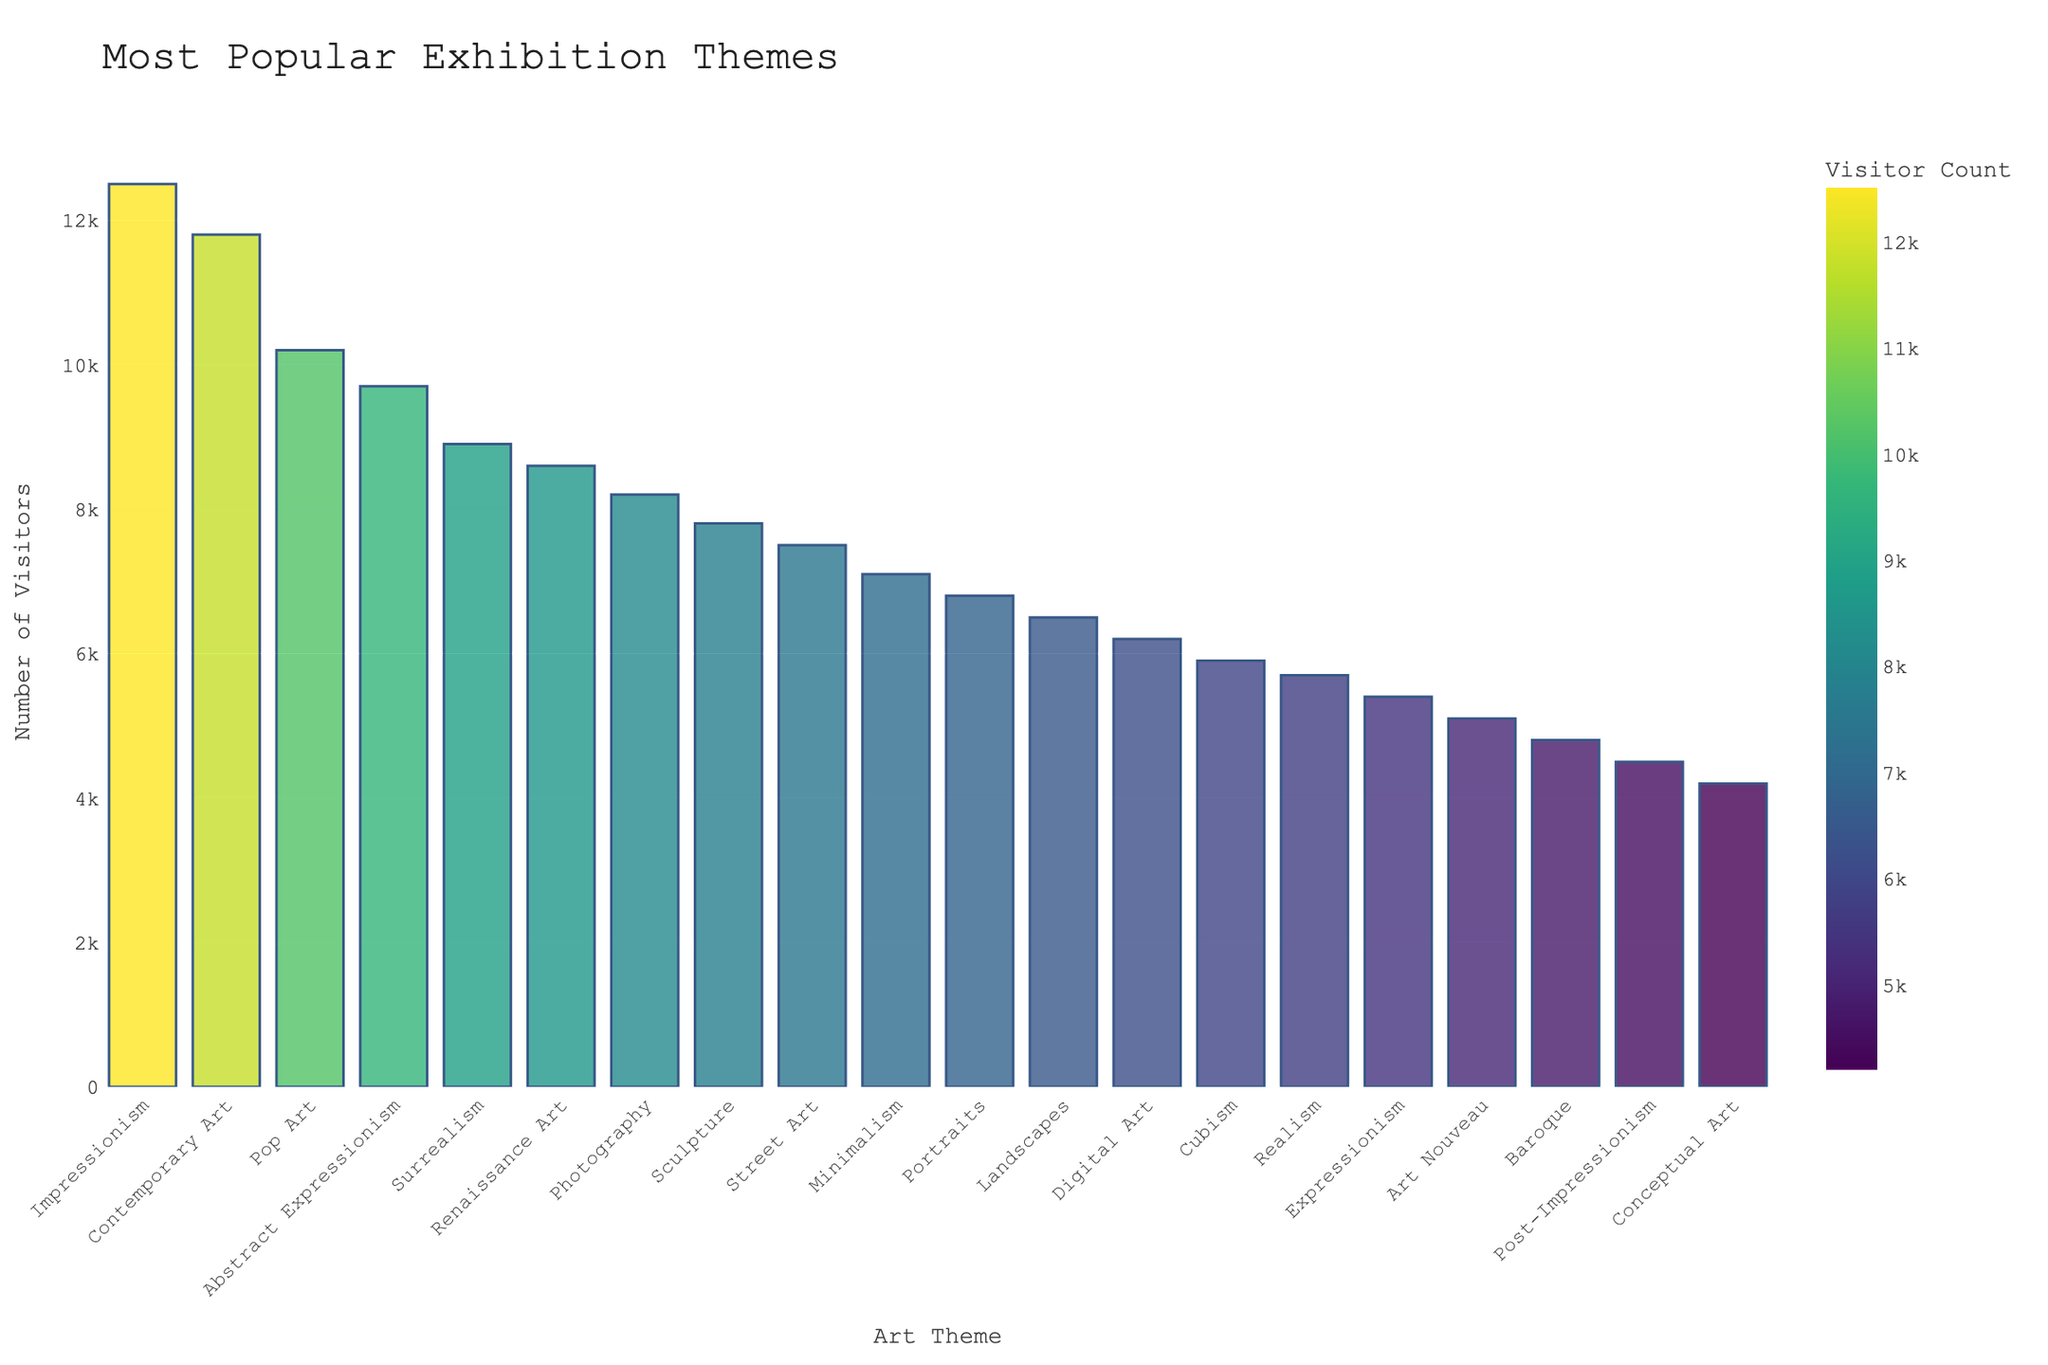What is the theme with the highest attendance? The tallest bar in the chart represents the theme with the highest attendance. This bar corresponds to Impressionism with an attendance of 12,500.
Answer: Impressionism How much higher is the attendance for Impressionism compared to Realism? Find the attendance for both themes: Impressionism (12,500) and Realism (5,700). Then, subtract the attendance of Realism from Impressionism: 12,500 - 5,700 = 6,800.
Answer: 6,800 Which theme has the lowest attendance? The shortest bar in the chart represents the theme with the lowest attendance. This bar corresponds to Conceptual Art with an attendance of 4,200.
Answer: Conceptual Art What is the total attendance for the top three most popular themes? The top three themes based on attendance are Impressionism (12,500), Contemporary Art (11,800), and Pop Art (10,200). Add these numbers together: 12,500 + 11,800 + 10,200 = 34,500.
Answer: 34,500 Which themes have an attendance greater than 10,000? Identify the bars that have heights surpassing the 10,000 attendance mark. These themes are Impressionism (12,500), Contemporary Art (11,800), and Pop Art (10,200).
Answer: Impressionism, Contemporary Art, Pop Art How many themes have an attendance between 6,000 and 9,000? Identify and count the bars whose attendance values fall within the range of 6,000 to 9,000. These themes are Surrealism (8,900), Renaissance Art (8,600), Photography (8,200), Sculpture (7,800), Street Art (7,500), Minimalism (7,100), Portraits (6,800), and Landscapes (6,500). Therefore, there are 8 themes within this range.
Answer: 8 What is the median attendance of all themes? Organize the attendance values in ascending order: 4,200, 4,500, 5,100, 5,400, 5,700, 5,900, 6,200, 6,500, 6,800, 7,100, 7,500, 7,800, 8,200, 8,600, 8,900, 9,700, 10,200, 11,800, 12,500. Since there are 20 themes, the median is the average of the 10th and 11th values: (7,100 + 7,500) / 2 = 7,300.
Answer: 7,300 Which theme has a similar attendance as Surrealism? Find the bar closest in height to Surrealism (8,900). The theme Renaissance Art has a similar attendance with 8,600.
Answer: Renaissance Art By how much does the attendance of Abstract Expressionism exceed that of Baroque? First, find the attendance values: Abstract Expressionism (9,700) and Baroque (4,800). Subtract the attendance of Baroque from Abstract Expressionism: 9,700 - 4,800 = 4,900.
Answer: 4,900 What is the combined attendance of Digital Art, Cubism, and Realism? Summing the attendance values for Digital Art (6,200), Cubism (5,900), and Realism (5,700) provides: 6,200 + 5,900 + 5,700 = 17,800.
Answer: 17,800 